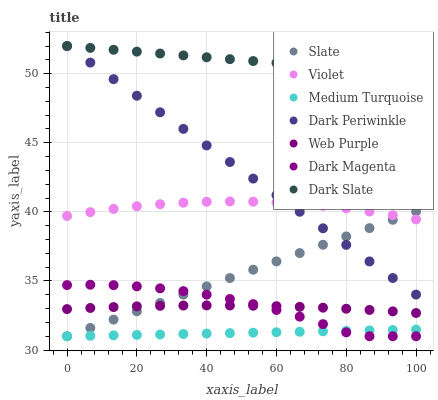Does Medium Turquoise have the minimum area under the curve?
Answer yes or no. Yes. Does Dark Slate have the maximum area under the curve?
Answer yes or no. Yes. Does Slate have the minimum area under the curve?
Answer yes or no. No. Does Slate have the maximum area under the curve?
Answer yes or no. No. Is Slate the smoothest?
Answer yes or no. Yes. Is Dark Magenta the roughest?
Answer yes or no. Yes. Is Dark Slate the smoothest?
Answer yes or no. No. Is Dark Slate the roughest?
Answer yes or no. No. Does Dark Magenta have the lowest value?
Answer yes or no. Yes. Does Dark Slate have the lowest value?
Answer yes or no. No. Does Dark Periwinkle have the highest value?
Answer yes or no. Yes. Does Slate have the highest value?
Answer yes or no. No. Is Medium Turquoise less than Dark Periwinkle?
Answer yes or no. Yes. Is Dark Slate greater than Dark Magenta?
Answer yes or no. Yes. Does Slate intersect Violet?
Answer yes or no. Yes. Is Slate less than Violet?
Answer yes or no. No. Is Slate greater than Violet?
Answer yes or no. No. Does Medium Turquoise intersect Dark Periwinkle?
Answer yes or no. No. 